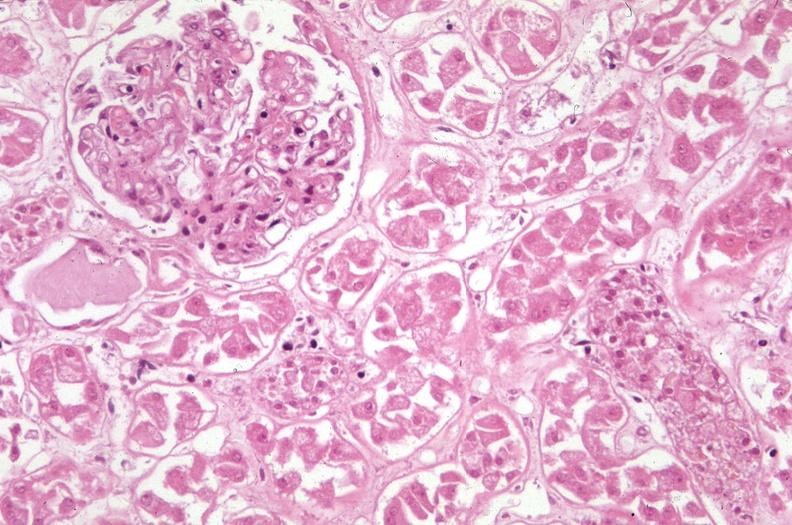where is this?
Answer the question using a single word or phrase. Urinary 